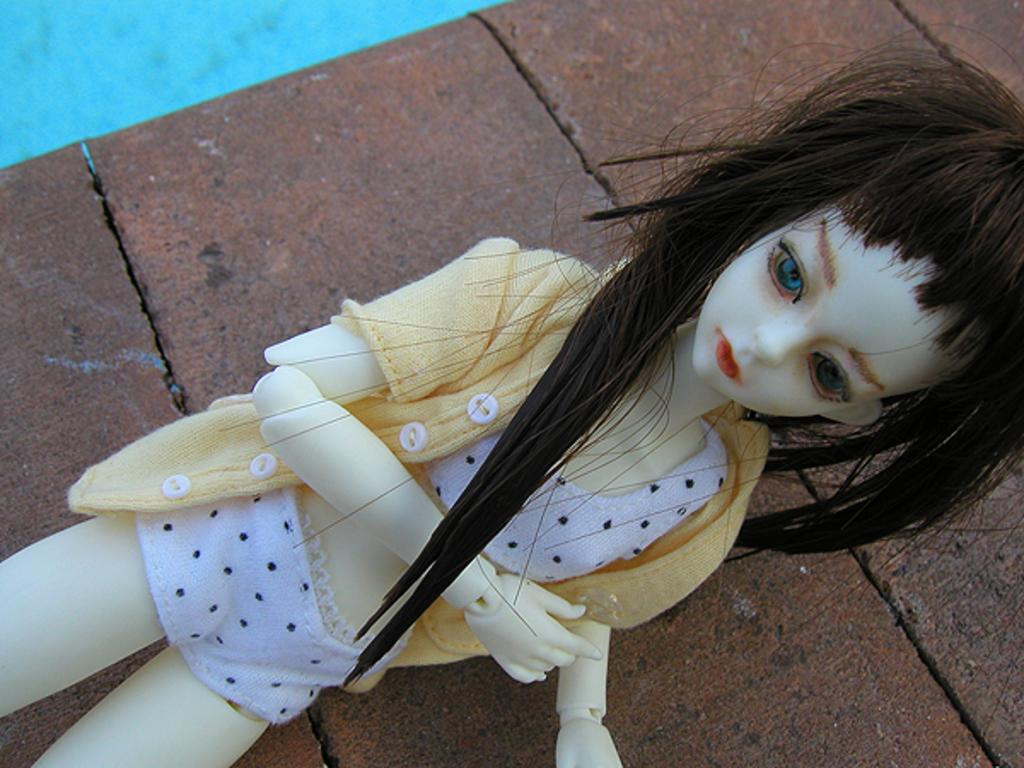What is placed on the floor in the image? There is a Barbie doll placed on the floor. What type of war is depicted in the image? There is no war depicted in the image; it features a Barbie doll placed on the floor. How many bikes are visible in the image? There are no bikes present in the image. 